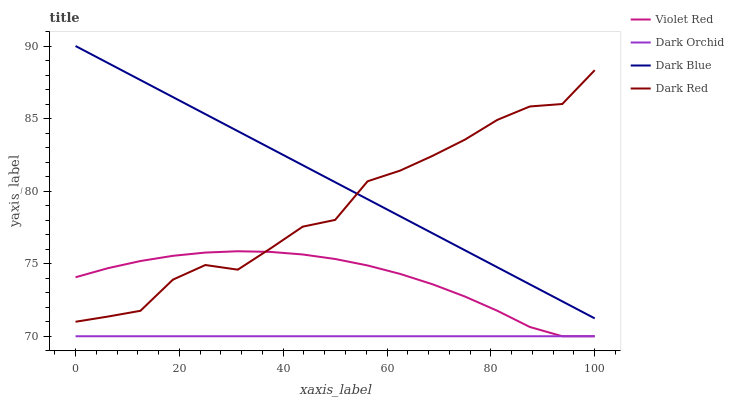Does Dark Orchid have the minimum area under the curve?
Answer yes or no. Yes. Does Dark Blue have the maximum area under the curve?
Answer yes or no. Yes. Does Violet Red have the minimum area under the curve?
Answer yes or no. No. Does Violet Red have the maximum area under the curve?
Answer yes or no. No. Is Dark Orchid the smoothest?
Answer yes or no. Yes. Is Dark Red the roughest?
Answer yes or no. Yes. Is Violet Red the smoothest?
Answer yes or no. No. Is Violet Red the roughest?
Answer yes or no. No. Does Violet Red have the lowest value?
Answer yes or no. Yes. Does Dark Red have the lowest value?
Answer yes or no. No. Does Dark Blue have the highest value?
Answer yes or no. Yes. Does Violet Red have the highest value?
Answer yes or no. No. Is Violet Red less than Dark Blue?
Answer yes or no. Yes. Is Dark Red greater than Dark Orchid?
Answer yes or no. Yes. Does Dark Orchid intersect Violet Red?
Answer yes or no. Yes. Is Dark Orchid less than Violet Red?
Answer yes or no. No. Is Dark Orchid greater than Violet Red?
Answer yes or no. No. Does Violet Red intersect Dark Blue?
Answer yes or no. No. 